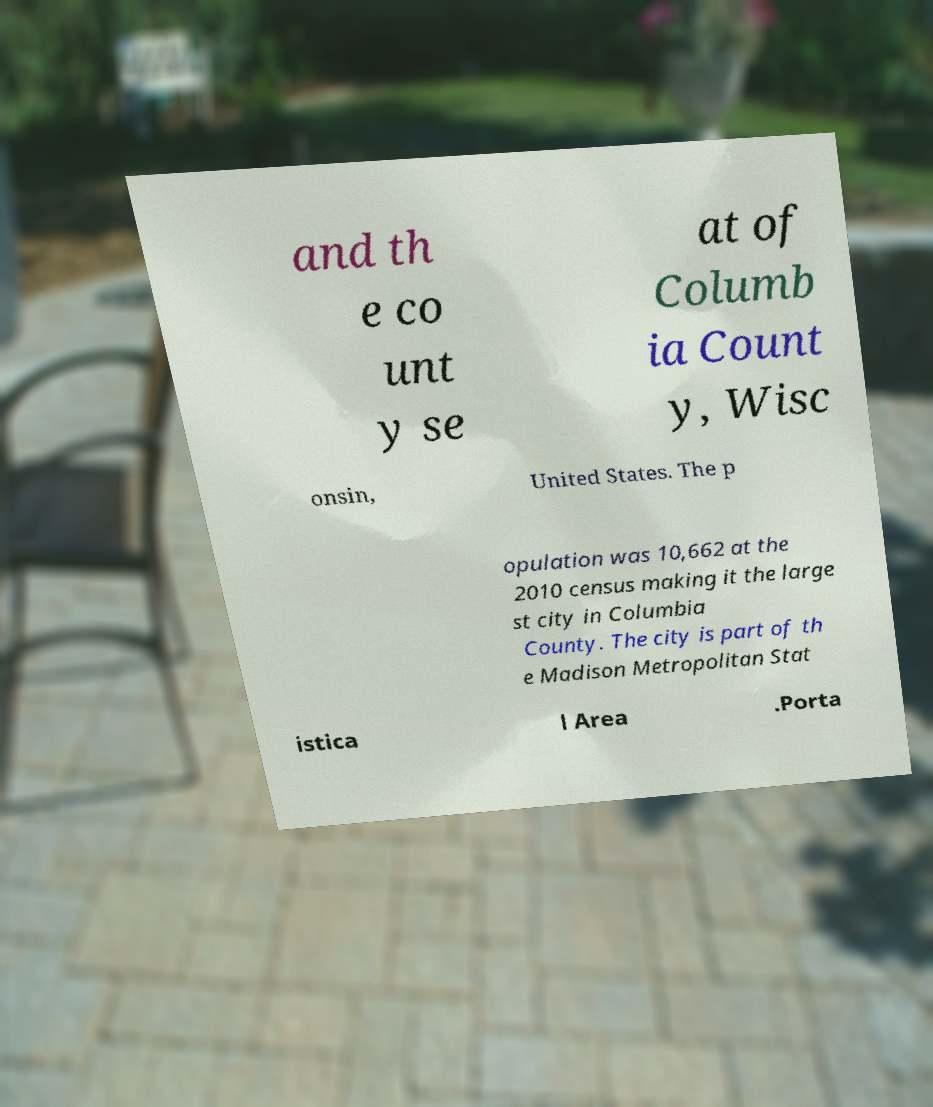For documentation purposes, I need the text within this image transcribed. Could you provide that? and th e co unt y se at of Columb ia Count y, Wisc onsin, United States. The p opulation was 10,662 at the 2010 census making it the large st city in Columbia County. The city is part of th e Madison Metropolitan Stat istica l Area .Porta 